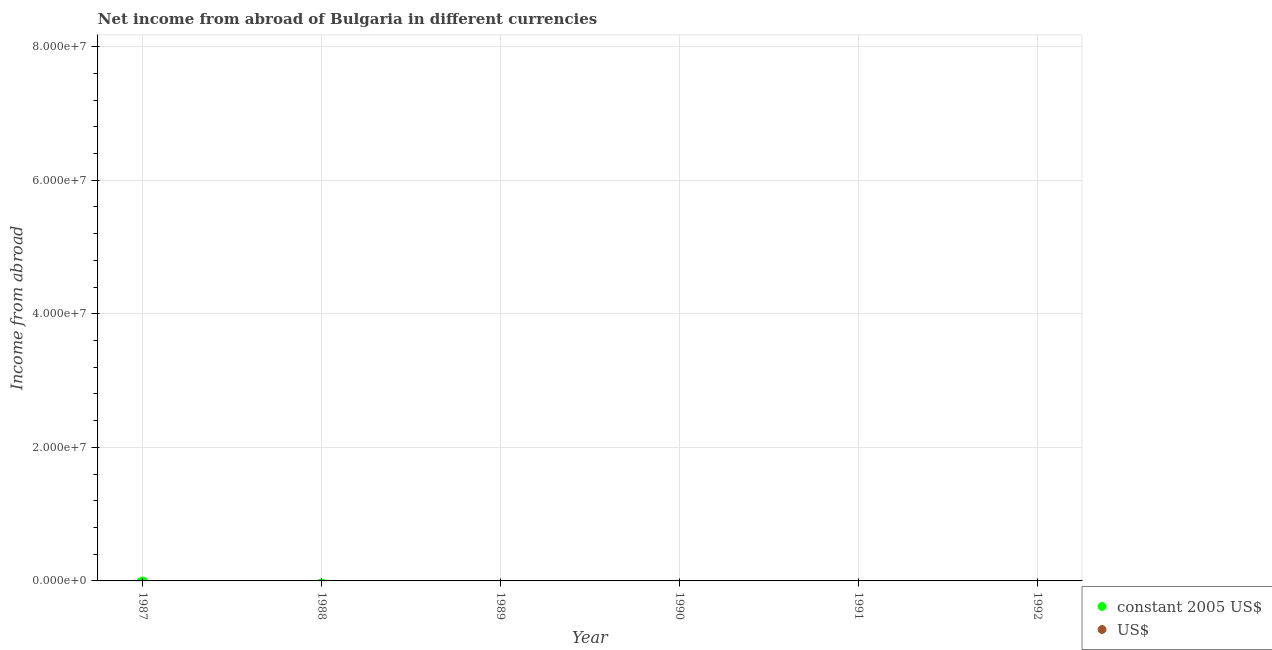Across all years, what is the minimum income from abroad in us$?
Ensure brevity in your answer.  0. What is the total income from abroad in us$ in the graph?
Your response must be concise. 0. What is the difference between the income from abroad in constant 2005 us$ in 1988 and the income from abroad in us$ in 1992?
Make the answer very short. 0. What is the average income from abroad in us$ per year?
Ensure brevity in your answer.  0. In how many years, is the income from abroad in us$ greater than the average income from abroad in us$ taken over all years?
Provide a short and direct response. 0. How many dotlines are there?
Offer a very short reply. 0. Does the graph contain any zero values?
Make the answer very short. Yes. How many legend labels are there?
Offer a terse response. 2. What is the title of the graph?
Your answer should be very brief. Net income from abroad of Bulgaria in different currencies. What is the label or title of the Y-axis?
Ensure brevity in your answer.  Income from abroad. What is the Income from abroad of constant 2005 US$ in 1988?
Offer a very short reply. 0. What is the Income from abroad of US$ in 1988?
Give a very brief answer. 0. What is the Income from abroad in constant 2005 US$ in 1989?
Provide a short and direct response. 0. What is the Income from abroad of US$ in 1989?
Offer a very short reply. 0. What is the Income from abroad in US$ in 1990?
Offer a very short reply. 0. What is the Income from abroad in constant 2005 US$ in 1991?
Offer a very short reply. 0. What is the Income from abroad in US$ in 1991?
Provide a short and direct response. 0. What is the Income from abroad of constant 2005 US$ in 1992?
Give a very brief answer. 0. What is the total Income from abroad in constant 2005 US$ in the graph?
Offer a terse response. 0. What is the average Income from abroad in US$ per year?
Your answer should be compact. 0. 